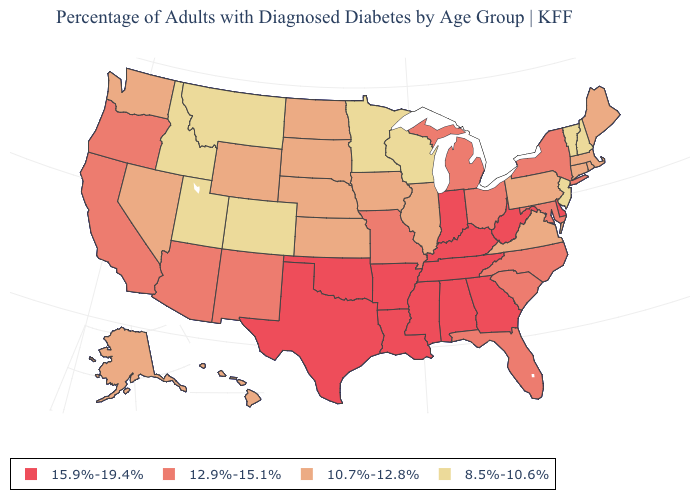Does Minnesota have the lowest value in the USA?
Quick response, please. Yes. Does Indiana have the highest value in the MidWest?
Quick response, please. Yes. Does Georgia have the lowest value in the South?
Concise answer only. No. Does the map have missing data?
Short answer required. No. What is the highest value in the USA?
Write a very short answer. 15.9%-19.4%. Name the states that have a value in the range 10.7%-12.8%?
Give a very brief answer. Alaska, Connecticut, Hawaii, Illinois, Iowa, Kansas, Maine, Massachusetts, Nebraska, Nevada, North Dakota, Pennsylvania, Rhode Island, South Dakota, Virginia, Washington, Wyoming. What is the value of Missouri?
Write a very short answer. 12.9%-15.1%. What is the value of Ohio?
Keep it brief. 12.9%-15.1%. What is the highest value in states that border Oregon?
Be succinct. 12.9%-15.1%. Does the map have missing data?
Be succinct. No. Name the states that have a value in the range 8.5%-10.6%?
Keep it brief. Colorado, Idaho, Minnesota, Montana, New Hampshire, New Jersey, Utah, Vermont, Wisconsin. Does Georgia have the highest value in the USA?
Keep it brief. Yes. Is the legend a continuous bar?
Short answer required. No. What is the lowest value in states that border Michigan?
Concise answer only. 8.5%-10.6%. What is the highest value in the MidWest ?
Be succinct. 15.9%-19.4%. 